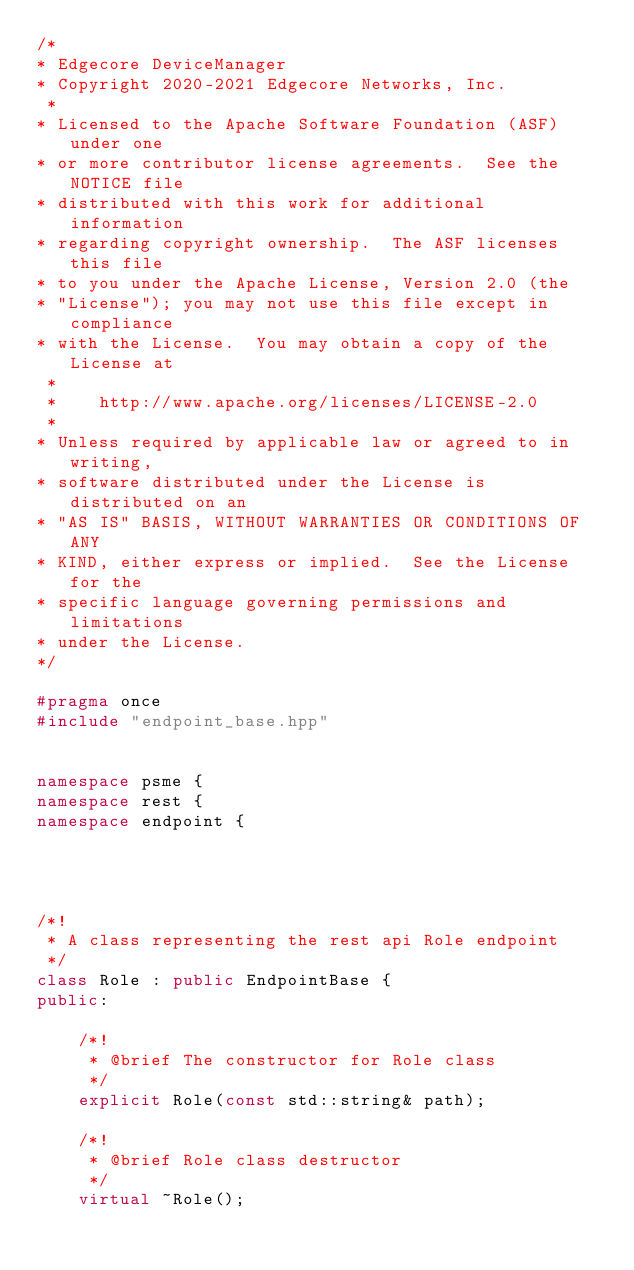Convert code to text. <code><loc_0><loc_0><loc_500><loc_500><_C++_>/*
* Edgecore DeviceManager
* Copyright 2020-2021 Edgecore Networks, Inc.
 *
* Licensed to the Apache Software Foundation (ASF) under one
* or more contributor license agreements.  See the NOTICE file
* distributed with this work for additional information
* regarding copyright ownership.  The ASF licenses this file
* to you under the Apache License, Version 2.0 (the
* "License"); you may not use this file except in compliance
* with the License.  You may obtain a copy of the License at
 *
 *    http://www.apache.org/licenses/LICENSE-2.0
 *
* Unless required by applicable law or agreed to in writing,
* software distributed under the License is distributed on an
* "AS IS" BASIS, WITHOUT WARRANTIES OR CONDITIONS OF ANY
* KIND, either express or implied.  See the License for the
* specific language governing permissions and limitations
* under the License.
*/

#pragma once
#include "endpoint_base.hpp"


namespace psme {
namespace rest {
namespace endpoint {




/*!
 * A class representing the rest api Role endpoint
 */
class Role : public EndpointBase {
public:

    /*!
     * @brief The constructor for Role class
     */
    explicit Role(const std::string& path);

    /*!
     * @brief Role class destructor
     */
    virtual ~Role();
</code> 